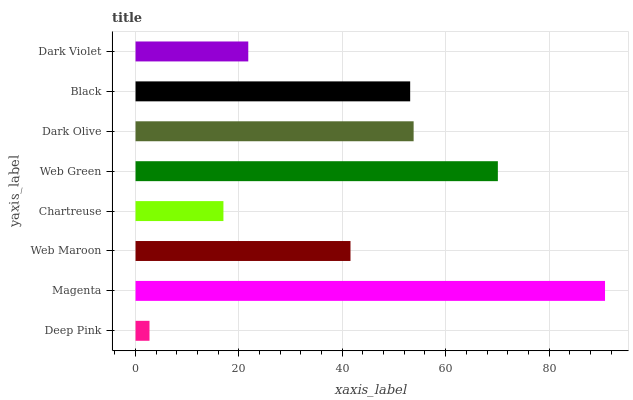Is Deep Pink the minimum?
Answer yes or no. Yes. Is Magenta the maximum?
Answer yes or no. Yes. Is Web Maroon the minimum?
Answer yes or no. No. Is Web Maroon the maximum?
Answer yes or no. No. Is Magenta greater than Web Maroon?
Answer yes or no. Yes. Is Web Maroon less than Magenta?
Answer yes or no. Yes. Is Web Maroon greater than Magenta?
Answer yes or no. No. Is Magenta less than Web Maroon?
Answer yes or no. No. Is Black the high median?
Answer yes or no. Yes. Is Web Maroon the low median?
Answer yes or no. Yes. Is Web Green the high median?
Answer yes or no. No. Is Black the low median?
Answer yes or no. No. 